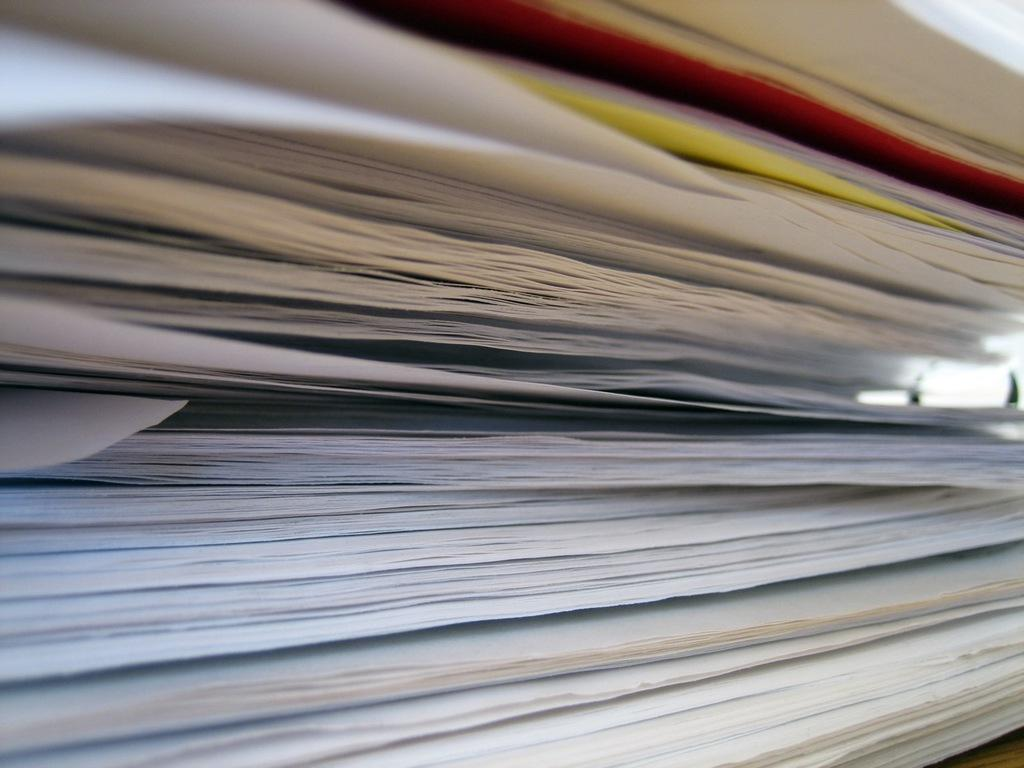What type of objects can be seen in the image? There are papers in the image. Can you describe the colors of the papers? Some of the papers are red in color, and some are yellow in color. What type of copy machine is visible in the image? There is no copy machine present in the image; it only features papers in red and yellow colors. 